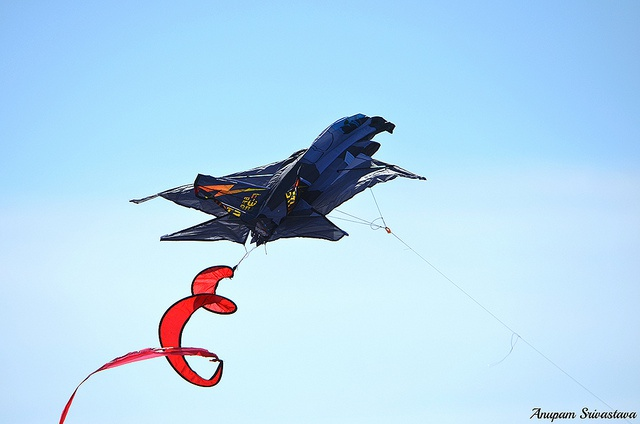Describe the objects in this image and their specific colors. I can see a kite in lightblue, black, navy, and gray tones in this image. 